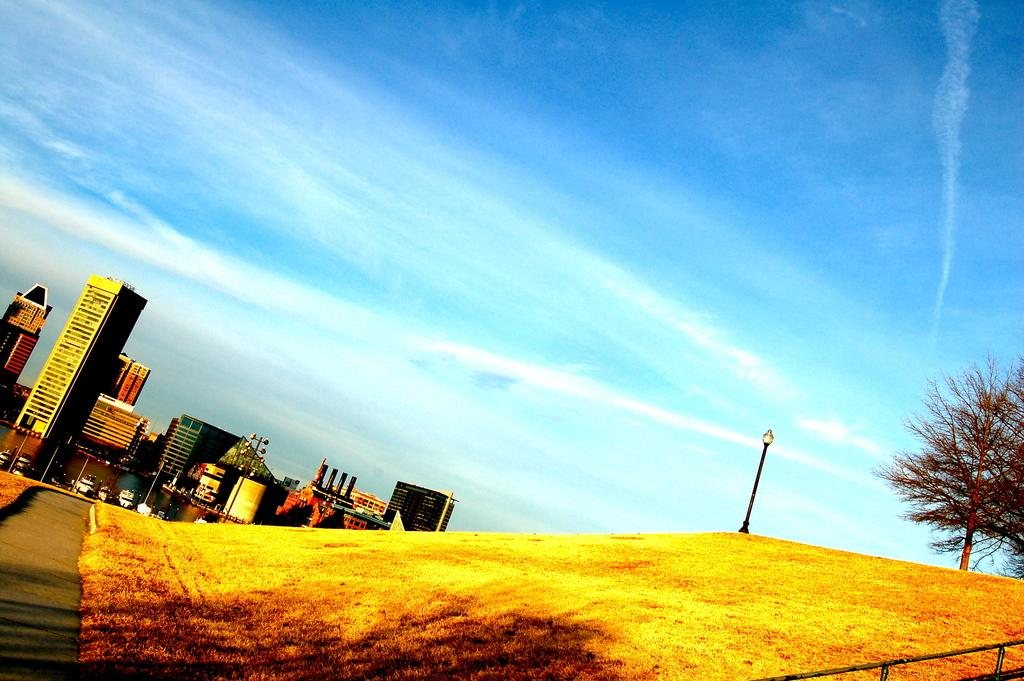What type of structures can be seen in the image? There are buildings in the image. What else is present in the image besides buildings? There are poles and trees in the image. What can be seen in the background of the image? The sky is visible in the background of the image. What type of plant is growing on the bone in the image? There is no plant or bone present in the image. 